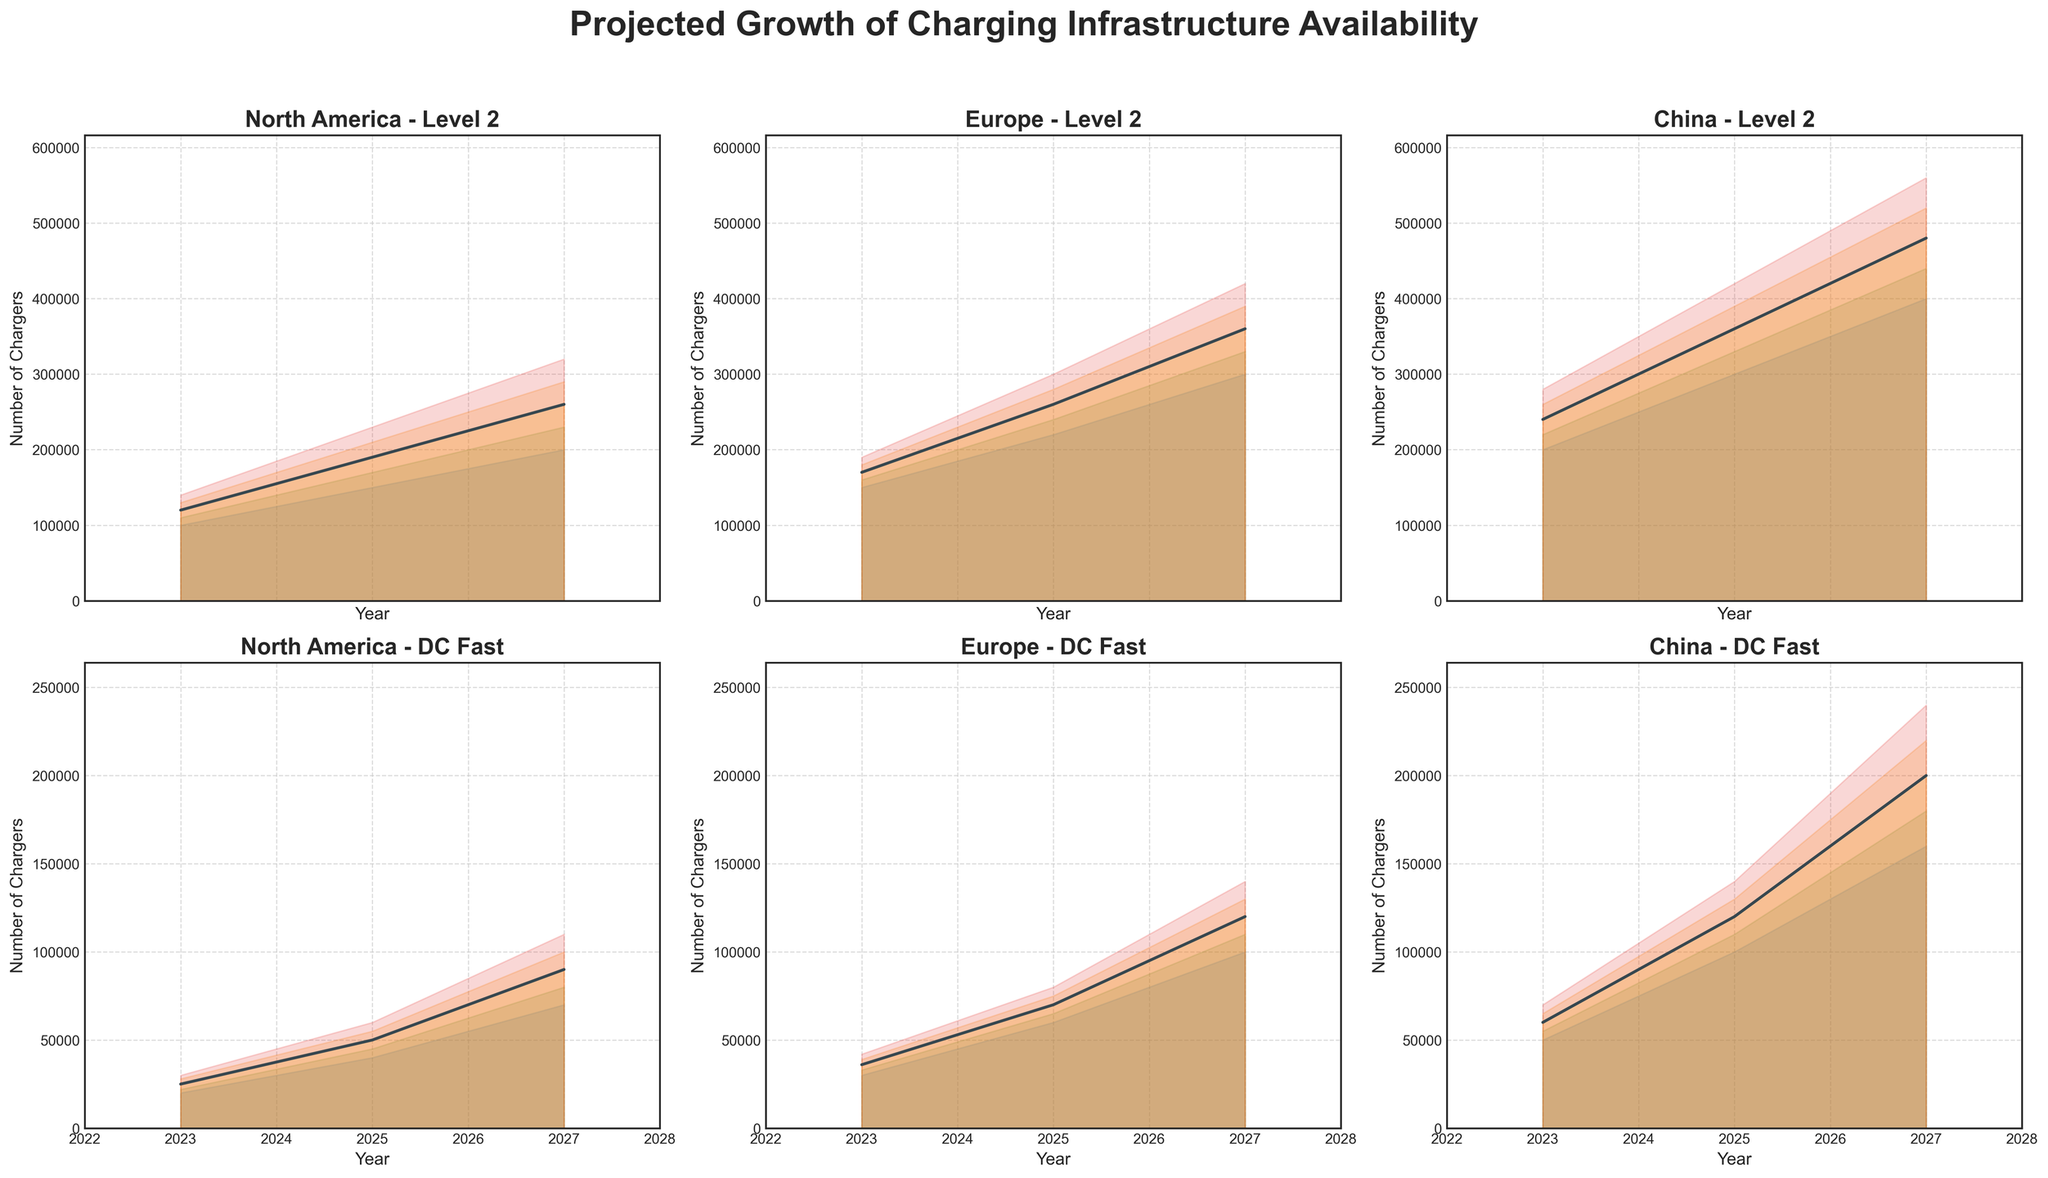What is the title of the chart? The title is located at the top of the chart and summarizes the overall content of the figure.
Answer: Projected Growth of Charging Infrastructure Availability How many regions are compared in the figure? By counting the number of individual sections along the figure's x-axis, each titled with a different region name.
Answer: 3 What are the three speeds of charging included in the data? By looking at the titles of each subplot which list the charging speeds.
Answer: Level 2, DC Fast Which region has the highest projected number of Level 2 chargers in 2027? Analyze the 'Level 2' projections for all regions and compare their upper bounds for the year 2027.
Answer: China What is the range of projected DC Fast chargers for North America in 2025? Find the projections for North America in 2025 for DC Fast chargers and note the lowest (Low) and highest (High) values in the range.
Answer: 40,000 to 60,000 Which year has the largest expected gap between high and low projections for Europe's DC Fast chargers? Explain the logical steps to determine the gap. Calculate the difference between 'High' and 'Low' projections for Europe DC Fast chargers for each year and compare the differences.
Answer: 2027 In 2025, which region has the greater number of projected chargers when combining both Level 2 and DC Fast projections? Detail the combinations step-by-step. Add the 'Mid' projections for Level 2 and DC Fast for each region in 2025, then compare the sums.
Answer: China Does the trend for the mid-projection values increase, decrease, or stay mostly constant from 2023 to 2027 for Europe's Level 2 chargers? Observe the change in the 'Mid' line for Europe's Level 2 chargers over the years from 2023 to 2027.
Answer: Increase Comparing the projected growth, which shows better improvement between North America DC Fast in 2025 and North America Level 2 in 2027? Explain the steps involved in making this comparison. Examine the difference between 'Mid' values of North America DC Fast from 2023 to 2025 and compare it with the difference of North America Level 2 from 2025 to 2027.
Answer: North America Level 2 in 2027 Describe the general trend of Level 2 chargers in China from 2023 to 2027 based on the chart. Note the changes in values from the beginning to the end of the observed period for Level 2 chargers in China.
Answer: Increasing 